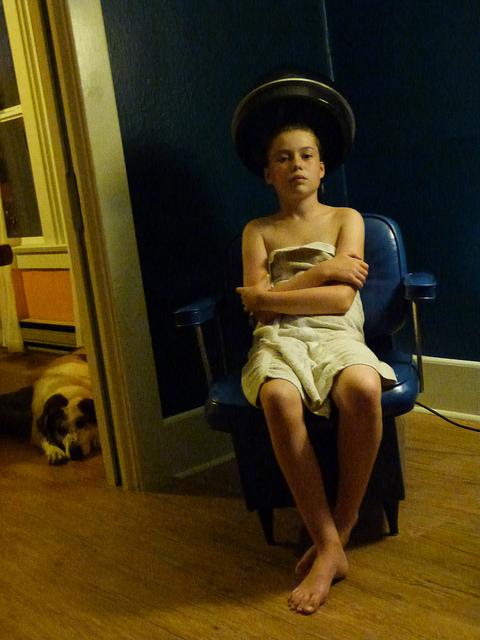What is she sitting on?
Keep it brief. Chair. Is this person wearing pants?
Write a very short answer. No. Is the man planning to take a shower?
Quick response, please. No. Is he naked?
Quick response, please. No. Why is he shirtless?
Concise answer only. Haircut. Is the dog begging for table scraps?
Give a very brief answer. No. What is the girl doing?
Write a very short answer. Sitting. Is the dog on harness?
Quick response, please. No. Is the person athletic?
Concise answer only. No. What is the kid doing?
Answer briefly. Sitting. Is she getting her hair dryer?
Quick response, please. Yes. Is this in color?
Answer briefly. Yes. What does the woman have on her feet?
Write a very short answer. Nothing. 